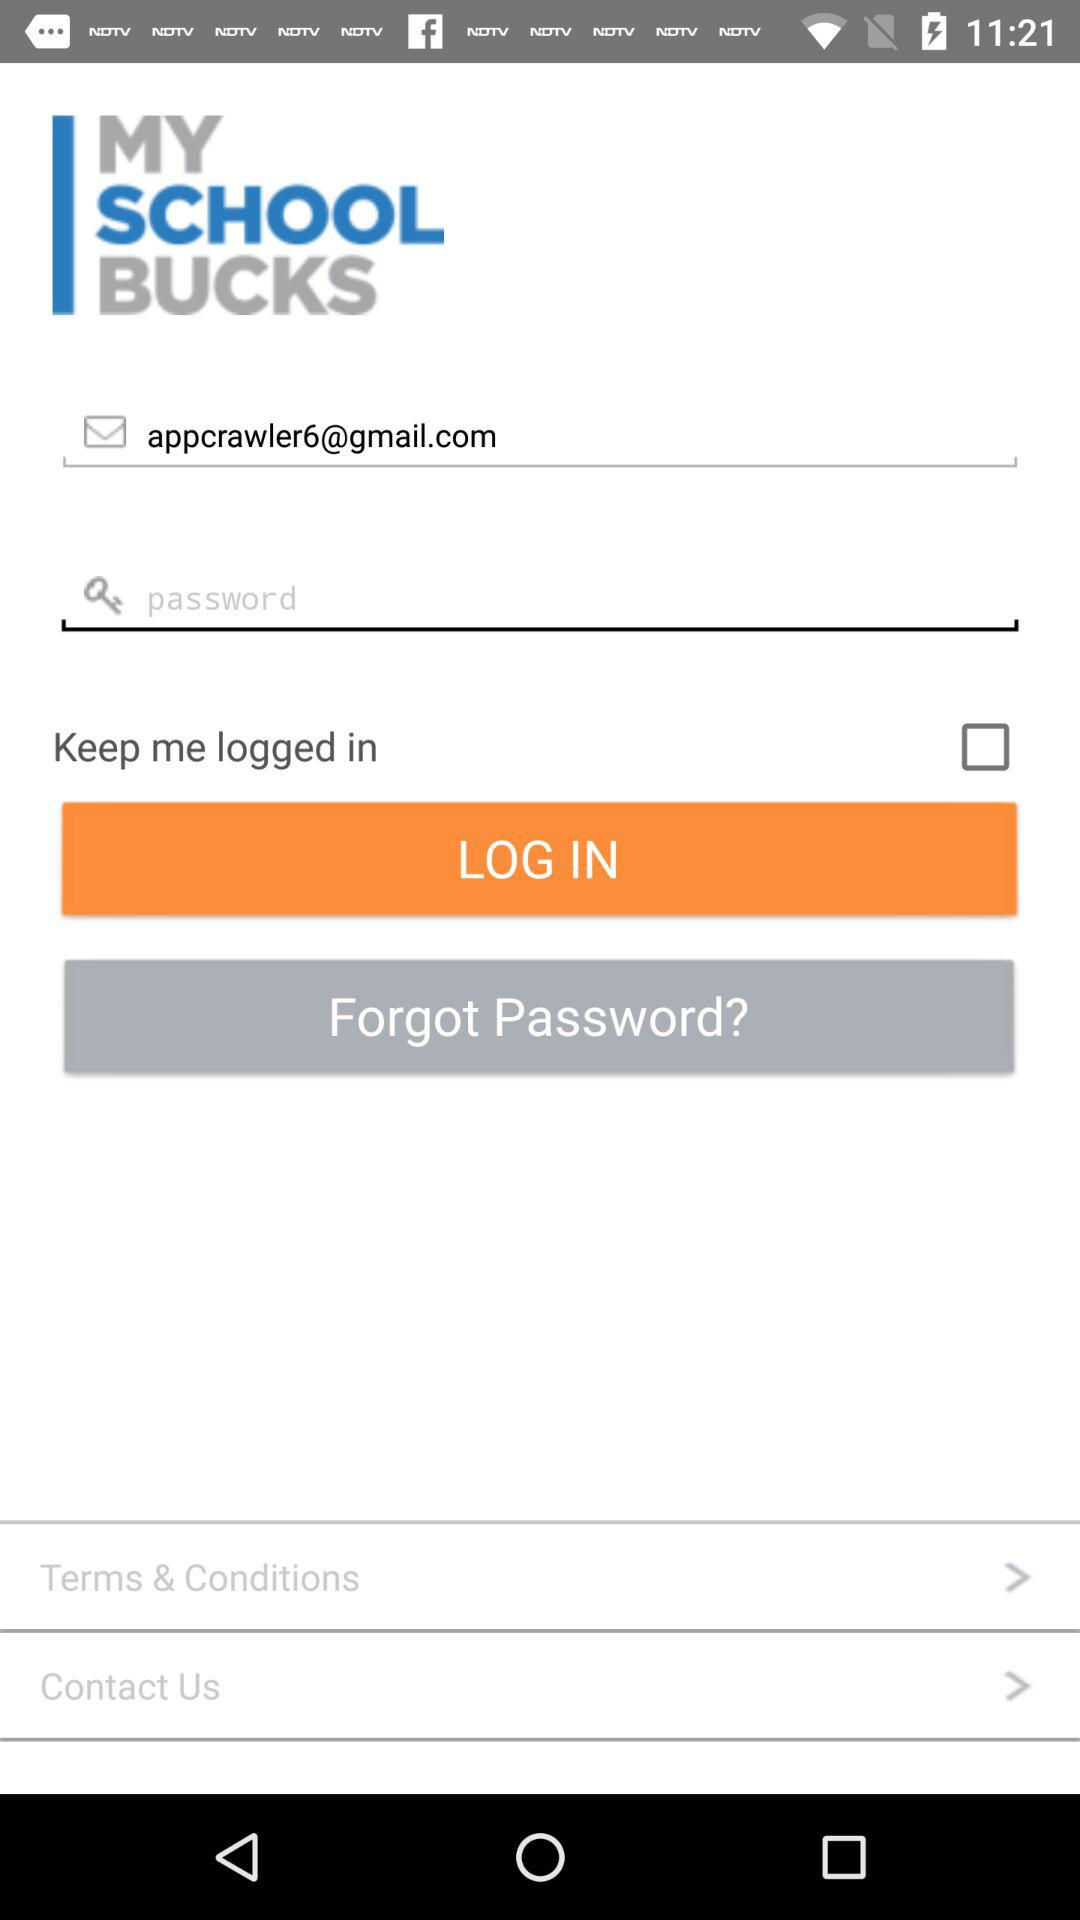Which options are given for contacting "MY SCHOOL BUCKS"?
When the provided information is insufficient, respond with <no answer>. <no answer> 